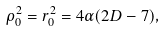Convert formula to latex. <formula><loc_0><loc_0><loc_500><loc_500>\rho _ { 0 } ^ { 2 } = r _ { 0 } ^ { 2 } = 4 \alpha ( 2 D - 7 ) ,</formula> 